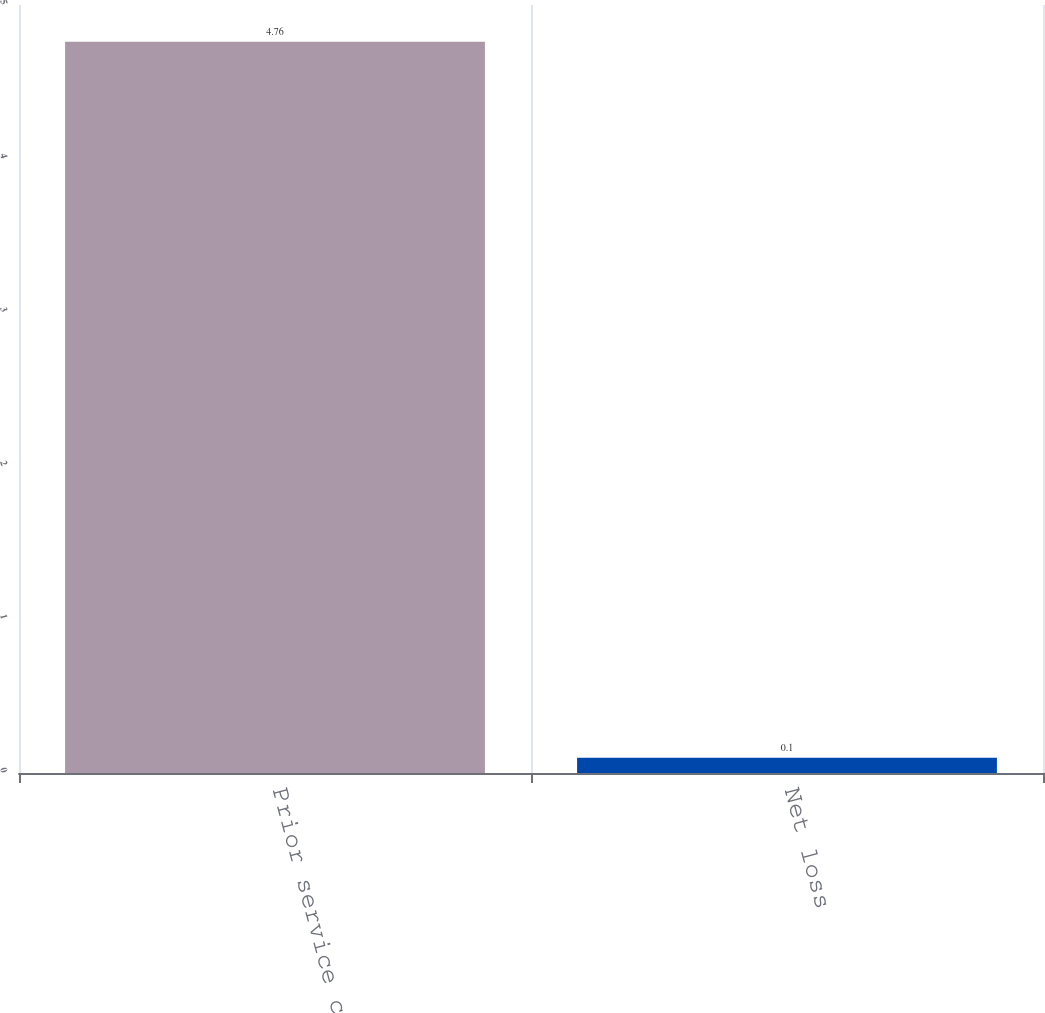<chart> <loc_0><loc_0><loc_500><loc_500><bar_chart><fcel>Prior service cost<fcel>Net loss<nl><fcel>4.76<fcel>0.1<nl></chart> 